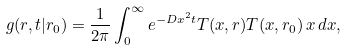Convert formula to latex. <formula><loc_0><loc_0><loc_500><loc_500>g ( r , t | r _ { 0 } ) = \frac { 1 } { 2 \pi } \int ^ { \infty } _ { 0 } e ^ { - D x ^ { 2 } t } T ( x , r ) T ( x , r _ { 0 } ) \, x \, d x ,</formula> 